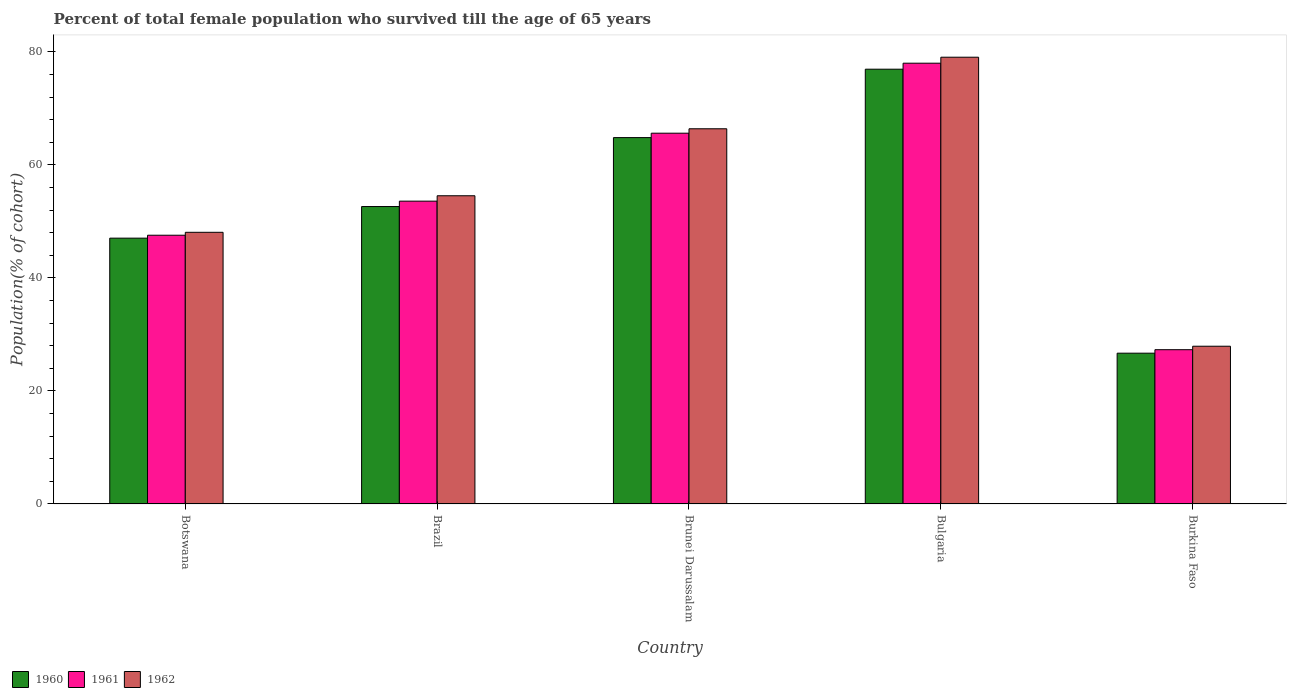How many groups of bars are there?
Your response must be concise. 5. Are the number of bars per tick equal to the number of legend labels?
Give a very brief answer. Yes. Are the number of bars on each tick of the X-axis equal?
Your answer should be very brief. Yes. How many bars are there on the 2nd tick from the left?
Your answer should be very brief. 3. What is the label of the 5th group of bars from the left?
Provide a short and direct response. Burkina Faso. In how many cases, is the number of bars for a given country not equal to the number of legend labels?
Provide a short and direct response. 0. What is the percentage of total female population who survived till the age of 65 years in 1962 in Botswana?
Make the answer very short. 48.07. Across all countries, what is the maximum percentage of total female population who survived till the age of 65 years in 1960?
Your response must be concise. 76.94. Across all countries, what is the minimum percentage of total female population who survived till the age of 65 years in 1961?
Give a very brief answer. 27.3. In which country was the percentage of total female population who survived till the age of 65 years in 1962 minimum?
Provide a short and direct response. Burkina Faso. What is the total percentage of total female population who survived till the age of 65 years in 1962 in the graph?
Your answer should be very brief. 275.99. What is the difference between the percentage of total female population who survived till the age of 65 years in 1960 in Botswana and that in Burkina Faso?
Make the answer very short. 20.36. What is the difference between the percentage of total female population who survived till the age of 65 years in 1961 in Botswana and the percentage of total female population who survived till the age of 65 years in 1962 in Brazil?
Your answer should be compact. -6.99. What is the average percentage of total female population who survived till the age of 65 years in 1962 per country?
Give a very brief answer. 55.2. What is the difference between the percentage of total female population who survived till the age of 65 years of/in 1962 and percentage of total female population who survived till the age of 65 years of/in 1961 in Brazil?
Make the answer very short. 0.95. What is the ratio of the percentage of total female population who survived till the age of 65 years in 1961 in Botswana to that in Brunei Darussalam?
Offer a terse response. 0.72. Is the percentage of total female population who survived till the age of 65 years in 1961 in Botswana less than that in Bulgaria?
Give a very brief answer. Yes. What is the difference between the highest and the second highest percentage of total female population who survived till the age of 65 years in 1961?
Ensure brevity in your answer.  12.03. What is the difference between the highest and the lowest percentage of total female population who survived till the age of 65 years in 1962?
Your answer should be compact. 51.14. In how many countries, is the percentage of total female population who survived till the age of 65 years in 1962 greater than the average percentage of total female population who survived till the age of 65 years in 1962 taken over all countries?
Make the answer very short. 2. What does the 1st bar from the right in Brazil represents?
Offer a very short reply. 1962. Are all the bars in the graph horizontal?
Provide a succinct answer. No. How many countries are there in the graph?
Offer a very short reply. 5. Are the values on the major ticks of Y-axis written in scientific E-notation?
Keep it short and to the point. No. Does the graph contain any zero values?
Ensure brevity in your answer.  No. Does the graph contain grids?
Your response must be concise. No. How are the legend labels stacked?
Offer a very short reply. Horizontal. What is the title of the graph?
Give a very brief answer. Percent of total female population who survived till the age of 65 years. What is the label or title of the X-axis?
Make the answer very short. Country. What is the label or title of the Y-axis?
Your answer should be very brief. Population(% of cohort). What is the Population(% of cohort) of 1960 in Botswana?
Make the answer very short. 47.04. What is the Population(% of cohort) of 1961 in Botswana?
Your answer should be compact. 47.56. What is the Population(% of cohort) in 1962 in Botswana?
Your answer should be compact. 48.07. What is the Population(% of cohort) in 1960 in Brazil?
Keep it short and to the point. 52.63. What is the Population(% of cohort) of 1961 in Brazil?
Your response must be concise. 53.59. What is the Population(% of cohort) in 1962 in Brazil?
Your answer should be compact. 54.54. What is the Population(% of cohort) in 1960 in Brunei Darussalam?
Make the answer very short. 64.83. What is the Population(% of cohort) in 1961 in Brunei Darussalam?
Provide a succinct answer. 65.61. What is the Population(% of cohort) of 1962 in Brunei Darussalam?
Your answer should be very brief. 66.4. What is the Population(% of cohort) of 1960 in Bulgaria?
Your answer should be compact. 76.94. What is the Population(% of cohort) in 1961 in Bulgaria?
Ensure brevity in your answer.  78. What is the Population(% of cohort) of 1962 in Bulgaria?
Ensure brevity in your answer.  79.06. What is the Population(% of cohort) in 1960 in Burkina Faso?
Make the answer very short. 26.68. What is the Population(% of cohort) of 1961 in Burkina Faso?
Make the answer very short. 27.3. What is the Population(% of cohort) of 1962 in Burkina Faso?
Keep it short and to the point. 27.92. Across all countries, what is the maximum Population(% of cohort) in 1960?
Ensure brevity in your answer.  76.94. Across all countries, what is the maximum Population(% of cohort) in 1961?
Your answer should be very brief. 78. Across all countries, what is the maximum Population(% of cohort) in 1962?
Provide a short and direct response. 79.06. Across all countries, what is the minimum Population(% of cohort) in 1960?
Offer a terse response. 26.68. Across all countries, what is the minimum Population(% of cohort) in 1961?
Provide a succinct answer. 27.3. Across all countries, what is the minimum Population(% of cohort) of 1962?
Your answer should be compact. 27.92. What is the total Population(% of cohort) in 1960 in the graph?
Provide a short and direct response. 268.13. What is the total Population(% of cohort) of 1961 in the graph?
Provide a short and direct response. 272.06. What is the total Population(% of cohort) of 1962 in the graph?
Ensure brevity in your answer.  275.99. What is the difference between the Population(% of cohort) in 1960 in Botswana and that in Brazil?
Your answer should be compact. -5.59. What is the difference between the Population(% of cohort) of 1961 in Botswana and that in Brazil?
Your answer should be compact. -6.03. What is the difference between the Population(% of cohort) in 1962 in Botswana and that in Brazil?
Give a very brief answer. -6.47. What is the difference between the Population(% of cohort) of 1960 in Botswana and that in Brunei Darussalam?
Your answer should be very brief. -17.79. What is the difference between the Population(% of cohort) of 1961 in Botswana and that in Brunei Darussalam?
Provide a succinct answer. -18.06. What is the difference between the Population(% of cohort) of 1962 in Botswana and that in Brunei Darussalam?
Your answer should be compact. -18.32. What is the difference between the Population(% of cohort) of 1960 in Botswana and that in Bulgaria?
Provide a short and direct response. -29.9. What is the difference between the Population(% of cohort) in 1961 in Botswana and that in Bulgaria?
Make the answer very short. -30.44. What is the difference between the Population(% of cohort) of 1962 in Botswana and that in Bulgaria?
Offer a very short reply. -30.99. What is the difference between the Population(% of cohort) in 1960 in Botswana and that in Burkina Faso?
Your response must be concise. 20.36. What is the difference between the Population(% of cohort) in 1961 in Botswana and that in Burkina Faso?
Your answer should be compact. 20.26. What is the difference between the Population(% of cohort) of 1962 in Botswana and that in Burkina Faso?
Give a very brief answer. 20.16. What is the difference between the Population(% of cohort) in 1960 in Brazil and that in Brunei Darussalam?
Your response must be concise. -12.2. What is the difference between the Population(% of cohort) of 1961 in Brazil and that in Brunei Darussalam?
Your answer should be very brief. -12.03. What is the difference between the Population(% of cohort) in 1962 in Brazil and that in Brunei Darussalam?
Offer a very short reply. -11.85. What is the difference between the Population(% of cohort) of 1960 in Brazil and that in Bulgaria?
Provide a short and direct response. -24.31. What is the difference between the Population(% of cohort) in 1961 in Brazil and that in Bulgaria?
Your answer should be compact. -24.41. What is the difference between the Population(% of cohort) of 1962 in Brazil and that in Bulgaria?
Your answer should be very brief. -24.52. What is the difference between the Population(% of cohort) in 1960 in Brazil and that in Burkina Faso?
Offer a very short reply. 25.95. What is the difference between the Population(% of cohort) in 1961 in Brazil and that in Burkina Faso?
Make the answer very short. 26.29. What is the difference between the Population(% of cohort) of 1962 in Brazil and that in Burkina Faso?
Offer a terse response. 26.63. What is the difference between the Population(% of cohort) of 1960 in Brunei Darussalam and that in Bulgaria?
Keep it short and to the point. -12.11. What is the difference between the Population(% of cohort) of 1961 in Brunei Darussalam and that in Bulgaria?
Your response must be concise. -12.39. What is the difference between the Population(% of cohort) of 1962 in Brunei Darussalam and that in Bulgaria?
Your response must be concise. -12.66. What is the difference between the Population(% of cohort) of 1960 in Brunei Darussalam and that in Burkina Faso?
Your answer should be compact. 38.15. What is the difference between the Population(% of cohort) of 1961 in Brunei Darussalam and that in Burkina Faso?
Your answer should be very brief. 38.31. What is the difference between the Population(% of cohort) of 1962 in Brunei Darussalam and that in Burkina Faso?
Provide a succinct answer. 38.48. What is the difference between the Population(% of cohort) of 1960 in Bulgaria and that in Burkina Faso?
Provide a short and direct response. 50.26. What is the difference between the Population(% of cohort) in 1961 in Bulgaria and that in Burkina Faso?
Keep it short and to the point. 50.7. What is the difference between the Population(% of cohort) in 1962 in Bulgaria and that in Burkina Faso?
Keep it short and to the point. 51.14. What is the difference between the Population(% of cohort) in 1960 in Botswana and the Population(% of cohort) in 1961 in Brazil?
Make the answer very short. -6.55. What is the difference between the Population(% of cohort) of 1960 in Botswana and the Population(% of cohort) of 1962 in Brazil?
Your answer should be compact. -7.5. What is the difference between the Population(% of cohort) of 1961 in Botswana and the Population(% of cohort) of 1962 in Brazil?
Your response must be concise. -6.99. What is the difference between the Population(% of cohort) of 1960 in Botswana and the Population(% of cohort) of 1961 in Brunei Darussalam?
Your answer should be very brief. -18.57. What is the difference between the Population(% of cohort) in 1960 in Botswana and the Population(% of cohort) in 1962 in Brunei Darussalam?
Offer a very short reply. -19.35. What is the difference between the Population(% of cohort) in 1961 in Botswana and the Population(% of cohort) in 1962 in Brunei Darussalam?
Your answer should be compact. -18.84. What is the difference between the Population(% of cohort) in 1960 in Botswana and the Population(% of cohort) in 1961 in Bulgaria?
Offer a very short reply. -30.96. What is the difference between the Population(% of cohort) in 1960 in Botswana and the Population(% of cohort) in 1962 in Bulgaria?
Your answer should be very brief. -32.02. What is the difference between the Population(% of cohort) in 1961 in Botswana and the Population(% of cohort) in 1962 in Bulgaria?
Your answer should be compact. -31.5. What is the difference between the Population(% of cohort) in 1960 in Botswana and the Population(% of cohort) in 1961 in Burkina Faso?
Provide a short and direct response. 19.74. What is the difference between the Population(% of cohort) in 1960 in Botswana and the Population(% of cohort) in 1962 in Burkina Faso?
Your answer should be very brief. 19.13. What is the difference between the Population(% of cohort) in 1961 in Botswana and the Population(% of cohort) in 1962 in Burkina Faso?
Make the answer very short. 19.64. What is the difference between the Population(% of cohort) in 1960 in Brazil and the Population(% of cohort) in 1961 in Brunei Darussalam?
Offer a very short reply. -12.98. What is the difference between the Population(% of cohort) in 1960 in Brazil and the Population(% of cohort) in 1962 in Brunei Darussalam?
Offer a very short reply. -13.76. What is the difference between the Population(% of cohort) in 1961 in Brazil and the Population(% of cohort) in 1962 in Brunei Darussalam?
Keep it short and to the point. -12.81. What is the difference between the Population(% of cohort) in 1960 in Brazil and the Population(% of cohort) in 1961 in Bulgaria?
Ensure brevity in your answer.  -25.36. What is the difference between the Population(% of cohort) of 1960 in Brazil and the Population(% of cohort) of 1962 in Bulgaria?
Ensure brevity in your answer.  -26.42. What is the difference between the Population(% of cohort) of 1961 in Brazil and the Population(% of cohort) of 1962 in Bulgaria?
Give a very brief answer. -25.47. What is the difference between the Population(% of cohort) in 1960 in Brazil and the Population(% of cohort) in 1961 in Burkina Faso?
Give a very brief answer. 25.33. What is the difference between the Population(% of cohort) in 1960 in Brazil and the Population(% of cohort) in 1962 in Burkina Faso?
Offer a terse response. 24.72. What is the difference between the Population(% of cohort) of 1961 in Brazil and the Population(% of cohort) of 1962 in Burkina Faso?
Your response must be concise. 25.67. What is the difference between the Population(% of cohort) of 1960 in Brunei Darussalam and the Population(% of cohort) of 1961 in Bulgaria?
Your answer should be compact. -13.17. What is the difference between the Population(% of cohort) of 1960 in Brunei Darussalam and the Population(% of cohort) of 1962 in Bulgaria?
Your response must be concise. -14.23. What is the difference between the Population(% of cohort) of 1961 in Brunei Darussalam and the Population(% of cohort) of 1962 in Bulgaria?
Make the answer very short. -13.45. What is the difference between the Population(% of cohort) in 1960 in Brunei Darussalam and the Population(% of cohort) in 1961 in Burkina Faso?
Give a very brief answer. 37.53. What is the difference between the Population(% of cohort) of 1960 in Brunei Darussalam and the Population(% of cohort) of 1962 in Burkina Faso?
Offer a very short reply. 36.92. What is the difference between the Population(% of cohort) of 1961 in Brunei Darussalam and the Population(% of cohort) of 1962 in Burkina Faso?
Your answer should be compact. 37.7. What is the difference between the Population(% of cohort) of 1960 in Bulgaria and the Population(% of cohort) of 1961 in Burkina Faso?
Provide a short and direct response. 49.64. What is the difference between the Population(% of cohort) of 1960 in Bulgaria and the Population(% of cohort) of 1962 in Burkina Faso?
Make the answer very short. 49.02. What is the difference between the Population(% of cohort) in 1961 in Bulgaria and the Population(% of cohort) in 1962 in Burkina Faso?
Your answer should be very brief. 50.08. What is the average Population(% of cohort) of 1960 per country?
Keep it short and to the point. 53.63. What is the average Population(% of cohort) in 1961 per country?
Give a very brief answer. 54.41. What is the average Population(% of cohort) in 1962 per country?
Offer a very short reply. 55.2. What is the difference between the Population(% of cohort) of 1960 and Population(% of cohort) of 1961 in Botswana?
Ensure brevity in your answer.  -0.52. What is the difference between the Population(% of cohort) in 1960 and Population(% of cohort) in 1962 in Botswana?
Your answer should be compact. -1.03. What is the difference between the Population(% of cohort) of 1961 and Population(% of cohort) of 1962 in Botswana?
Keep it short and to the point. -0.52. What is the difference between the Population(% of cohort) of 1960 and Population(% of cohort) of 1961 in Brazil?
Provide a succinct answer. -0.95. What is the difference between the Population(% of cohort) in 1960 and Population(% of cohort) in 1962 in Brazil?
Ensure brevity in your answer.  -1.91. What is the difference between the Population(% of cohort) of 1961 and Population(% of cohort) of 1962 in Brazil?
Provide a short and direct response. -0.95. What is the difference between the Population(% of cohort) in 1960 and Population(% of cohort) in 1961 in Brunei Darussalam?
Ensure brevity in your answer.  -0.78. What is the difference between the Population(% of cohort) in 1960 and Population(% of cohort) in 1962 in Brunei Darussalam?
Keep it short and to the point. -1.56. What is the difference between the Population(% of cohort) in 1961 and Population(% of cohort) in 1962 in Brunei Darussalam?
Your answer should be very brief. -0.78. What is the difference between the Population(% of cohort) in 1960 and Population(% of cohort) in 1961 in Bulgaria?
Give a very brief answer. -1.06. What is the difference between the Population(% of cohort) of 1960 and Population(% of cohort) of 1962 in Bulgaria?
Keep it short and to the point. -2.12. What is the difference between the Population(% of cohort) of 1961 and Population(% of cohort) of 1962 in Bulgaria?
Offer a very short reply. -1.06. What is the difference between the Population(% of cohort) in 1960 and Population(% of cohort) in 1961 in Burkina Faso?
Offer a terse response. -0.62. What is the difference between the Population(% of cohort) in 1960 and Population(% of cohort) in 1962 in Burkina Faso?
Your answer should be compact. -1.23. What is the difference between the Population(% of cohort) in 1961 and Population(% of cohort) in 1962 in Burkina Faso?
Provide a short and direct response. -0.62. What is the ratio of the Population(% of cohort) in 1960 in Botswana to that in Brazil?
Keep it short and to the point. 0.89. What is the ratio of the Population(% of cohort) of 1961 in Botswana to that in Brazil?
Give a very brief answer. 0.89. What is the ratio of the Population(% of cohort) in 1962 in Botswana to that in Brazil?
Ensure brevity in your answer.  0.88. What is the ratio of the Population(% of cohort) of 1960 in Botswana to that in Brunei Darussalam?
Give a very brief answer. 0.73. What is the ratio of the Population(% of cohort) of 1961 in Botswana to that in Brunei Darussalam?
Your answer should be compact. 0.72. What is the ratio of the Population(% of cohort) in 1962 in Botswana to that in Brunei Darussalam?
Provide a succinct answer. 0.72. What is the ratio of the Population(% of cohort) in 1960 in Botswana to that in Bulgaria?
Your response must be concise. 0.61. What is the ratio of the Population(% of cohort) in 1961 in Botswana to that in Bulgaria?
Your answer should be compact. 0.61. What is the ratio of the Population(% of cohort) in 1962 in Botswana to that in Bulgaria?
Your answer should be compact. 0.61. What is the ratio of the Population(% of cohort) in 1960 in Botswana to that in Burkina Faso?
Provide a short and direct response. 1.76. What is the ratio of the Population(% of cohort) in 1961 in Botswana to that in Burkina Faso?
Your response must be concise. 1.74. What is the ratio of the Population(% of cohort) of 1962 in Botswana to that in Burkina Faso?
Ensure brevity in your answer.  1.72. What is the ratio of the Population(% of cohort) of 1960 in Brazil to that in Brunei Darussalam?
Your answer should be compact. 0.81. What is the ratio of the Population(% of cohort) in 1961 in Brazil to that in Brunei Darussalam?
Offer a terse response. 0.82. What is the ratio of the Population(% of cohort) in 1962 in Brazil to that in Brunei Darussalam?
Your answer should be very brief. 0.82. What is the ratio of the Population(% of cohort) in 1960 in Brazil to that in Bulgaria?
Provide a succinct answer. 0.68. What is the ratio of the Population(% of cohort) in 1961 in Brazil to that in Bulgaria?
Keep it short and to the point. 0.69. What is the ratio of the Population(% of cohort) of 1962 in Brazil to that in Bulgaria?
Offer a terse response. 0.69. What is the ratio of the Population(% of cohort) of 1960 in Brazil to that in Burkina Faso?
Ensure brevity in your answer.  1.97. What is the ratio of the Population(% of cohort) of 1961 in Brazil to that in Burkina Faso?
Offer a very short reply. 1.96. What is the ratio of the Population(% of cohort) in 1962 in Brazil to that in Burkina Faso?
Keep it short and to the point. 1.95. What is the ratio of the Population(% of cohort) in 1960 in Brunei Darussalam to that in Bulgaria?
Your answer should be compact. 0.84. What is the ratio of the Population(% of cohort) of 1961 in Brunei Darussalam to that in Bulgaria?
Your answer should be very brief. 0.84. What is the ratio of the Population(% of cohort) in 1962 in Brunei Darussalam to that in Bulgaria?
Make the answer very short. 0.84. What is the ratio of the Population(% of cohort) in 1960 in Brunei Darussalam to that in Burkina Faso?
Make the answer very short. 2.43. What is the ratio of the Population(% of cohort) in 1961 in Brunei Darussalam to that in Burkina Faso?
Your answer should be very brief. 2.4. What is the ratio of the Population(% of cohort) of 1962 in Brunei Darussalam to that in Burkina Faso?
Your answer should be compact. 2.38. What is the ratio of the Population(% of cohort) in 1960 in Bulgaria to that in Burkina Faso?
Offer a terse response. 2.88. What is the ratio of the Population(% of cohort) in 1961 in Bulgaria to that in Burkina Faso?
Ensure brevity in your answer.  2.86. What is the ratio of the Population(% of cohort) in 1962 in Bulgaria to that in Burkina Faso?
Offer a very short reply. 2.83. What is the difference between the highest and the second highest Population(% of cohort) in 1960?
Your response must be concise. 12.11. What is the difference between the highest and the second highest Population(% of cohort) of 1961?
Provide a succinct answer. 12.39. What is the difference between the highest and the second highest Population(% of cohort) of 1962?
Provide a short and direct response. 12.66. What is the difference between the highest and the lowest Population(% of cohort) in 1960?
Keep it short and to the point. 50.26. What is the difference between the highest and the lowest Population(% of cohort) in 1961?
Give a very brief answer. 50.7. What is the difference between the highest and the lowest Population(% of cohort) of 1962?
Your response must be concise. 51.14. 